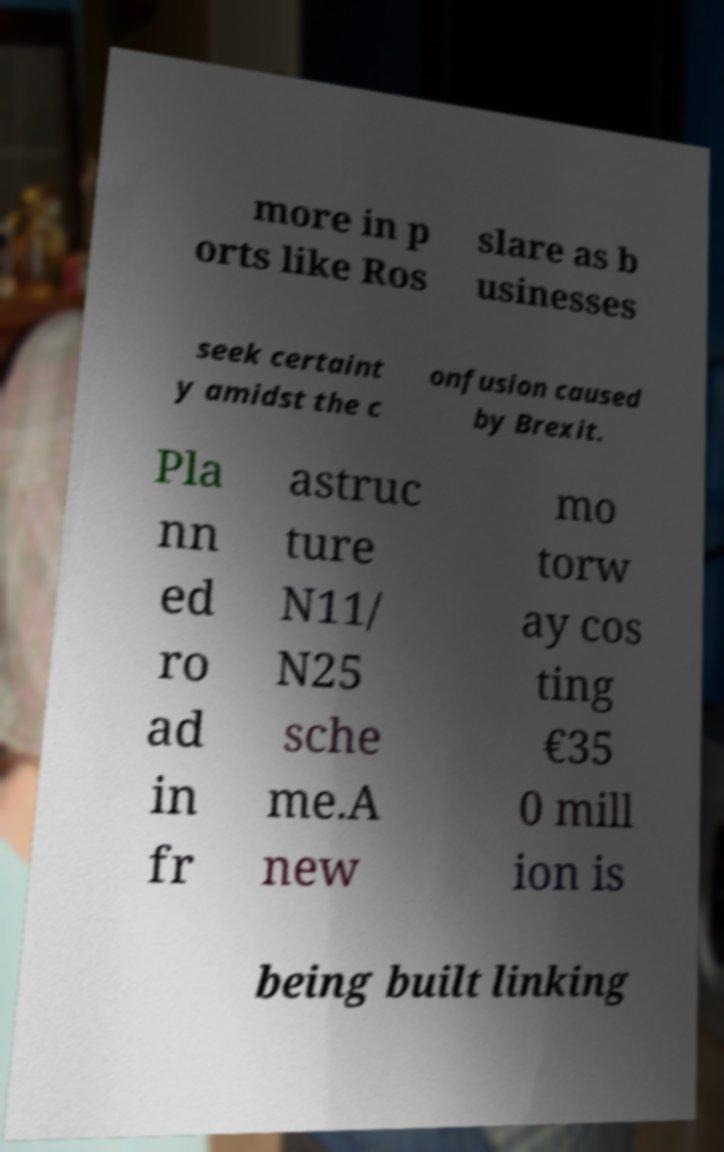For documentation purposes, I need the text within this image transcribed. Could you provide that? more in p orts like Ros slare as b usinesses seek certaint y amidst the c onfusion caused by Brexit. Pla nn ed ro ad in fr astruc ture N11/ N25 sche me.A new mo torw ay cos ting €35 0 mill ion is being built linking 